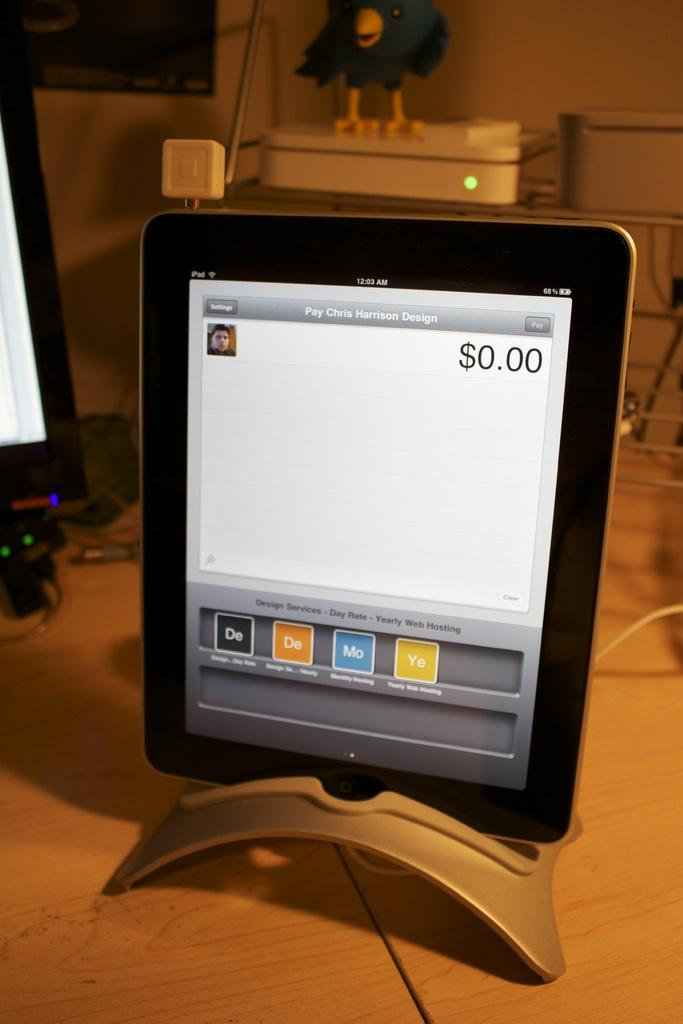<image>
Create a compact narrative representing the image presented. A tablet is open up to a screen where they are making a payment to Chris Harrison Design. 